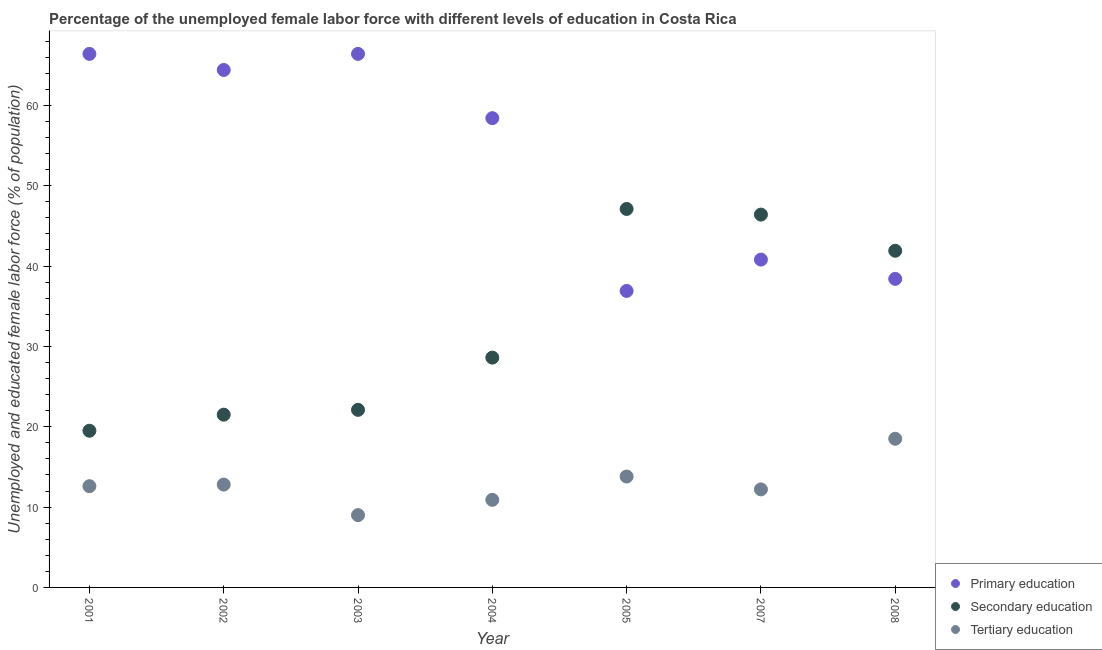What is the percentage of female labor force who received secondary education in 2005?
Keep it short and to the point. 47.1. What is the total percentage of female labor force who received tertiary education in the graph?
Provide a succinct answer. 89.8. What is the difference between the percentage of female labor force who received secondary education in 2001 and that in 2004?
Ensure brevity in your answer.  -9.1. What is the difference between the percentage of female labor force who received secondary education in 2005 and the percentage of female labor force who received tertiary education in 2008?
Your answer should be very brief. 28.6. What is the average percentage of female labor force who received primary education per year?
Provide a succinct answer. 53.1. In the year 2004, what is the difference between the percentage of female labor force who received tertiary education and percentage of female labor force who received secondary education?
Your answer should be very brief. -17.7. In how many years, is the percentage of female labor force who received primary education greater than 62 %?
Give a very brief answer. 3. What is the ratio of the percentage of female labor force who received primary education in 2001 to that in 2005?
Give a very brief answer. 1.8. Is the percentage of female labor force who received primary education in 2004 less than that in 2005?
Your answer should be very brief. No. What is the difference between the highest and the second highest percentage of female labor force who received secondary education?
Ensure brevity in your answer.  0.7. What is the difference between the highest and the lowest percentage of female labor force who received secondary education?
Your answer should be very brief. 27.6. In how many years, is the percentage of female labor force who received primary education greater than the average percentage of female labor force who received primary education taken over all years?
Make the answer very short. 4. Is the sum of the percentage of female labor force who received primary education in 2001 and 2008 greater than the maximum percentage of female labor force who received secondary education across all years?
Provide a short and direct response. Yes. Is the percentage of female labor force who received primary education strictly greater than the percentage of female labor force who received tertiary education over the years?
Your answer should be compact. Yes. Are the values on the major ticks of Y-axis written in scientific E-notation?
Give a very brief answer. No. Does the graph contain grids?
Offer a very short reply. No. Where does the legend appear in the graph?
Provide a succinct answer. Bottom right. How are the legend labels stacked?
Your response must be concise. Vertical. What is the title of the graph?
Provide a succinct answer. Percentage of the unemployed female labor force with different levels of education in Costa Rica. Does "Poland" appear as one of the legend labels in the graph?
Keep it short and to the point. No. What is the label or title of the X-axis?
Make the answer very short. Year. What is the label or title of the Y-axis?
Make the answer very short. Unemployed and educated female labor force (% of population). What is the Unemployed and educated female labor force (% of population) of Primary education in 2001?
Make the answer very short. 66.4. What is the Unemployed and educated female labor force (% of population) in Tertiary education in 2001?
Offer a very short reply. 12.6. What is the Unemployed and educated female labor force (% of population) of Primary education in 2002?
Your answer should be very brief. 64.4. What is the Unemployed and educated female labor force (% of population) of Tertiary education in 2002?
Provide a short and direct response. 12.8. What is the Unemployed and educated female labor force (% of population) of Primary education in 2003?
Make the answer very short. 66.4. What is the Unemployed and educated female labor force (% of population) in Secondary education in 2003?
Ensure brevity in your answer.  22.1. What is the Unemployed and educated female labor force (% of population) in Primary education in 2004?
Make the answer very short. 58.4. What is the Unemployed and educated female labor force (% of population) in Secondary education in 2004?
Ensure brevity in your answer.  28.6. What is the Unemployed and educated female labor force (% of population) in Tertiary education in 2004?
Give a very brief answer. 10.9. What is the Unemployed and educated female labor force (% of population) in Primary education in 2005?
Offer a terse response. 36.9. What is the Unemployed and educated female labor force (% of population) of Secondary education in 2005?
Your answer should be very brief. 47.1. What is the Unemployed and educated female labor force (% of population) of Tertiary education in 2005?
Provide a succinct answer. 13.8. What is the Unemployed and educated female labor force (% of population) of Primary education in 2007?
Provide a short and direct response. 40.8. What is the Unemployed and educated female labor force (% of population) in Secondary education in 2007?
Make the answer very short. 46.4. What is the Unemployed and educated female labor force (% of population) of Tertiary education in 2007?
Provide a short and direct response. 12.2. What is the Unemployed and educated female labor force (% of population) in Primary education in 2008?
Offer a very short reply. 38.4. What is the Unemployed and educated female labor force (% of population) in Secondary education in 2008?
Offer a terse response. 41.9. Across all years, what is the maximum Unemployed and educated female labor force (% of population) in Primary education?
Keep it short and to the point. 66.4. Across all years, what is the maximum Unemployed and educated female labor force (% of population) of Secondary education?
Your answer should be very brief. 47.1. Across all years, what is the maximum Unemployed and educated female labor force (% of population) of Tertiary education?
Your answer should be very brief. 18.5. Across all years, what is the minimum Unemployed and educated female labor force (% of population) in Primary education?
Make the answer very short. 36.9. Across all years, what is the minimum Unemployed and educated female labor force (% of population) of Secondary education?
Provide a succinct answer. 19.5. Across all years, what is the minimum Unemployed and educated female labor force (% of population) in Tertiary education?
Provide a succinct answer. 9. What is the total Unemployed and educated female labor force (% of population) in Primary education in the graph?
Give a very brief answer. 371.7. What is the total Unemployed and educated female labor force (% of population) in Secondary education in the graph?
Your response must be concise. 227.1. What is the total Unemployed and educated female labor force (% of population) in Tertiary education in the graph?
Keep it short and to the point. 89.8. What is the difference between the Unemployed and educated female labor force (% of population) of Primary education in 2001 and that in 2002?
Make the answer very short. 2. What is the difference between the Unemployed and educated female labor force (% of population) in Secondary education in 2001 and that in 2002?
Your answer should be very brief. -2. What is the difference between the Unemployed and educated female labor force (% of population) of Primary education in 2001 and that in 2003?
Keep it short and to the point. 0. What is the difference between the Unemployed and educated female labor force (% of population) of Primary education in 2001 and that in 2005?
Your response must be concise. 29.5. What is the difference between the Unemployed and educated female labor force (% of population) in Secondary education in 2001 and that in 2005?
Make the answer very short. -27.6. What is the difference between the Unemployed and educated female labor force (% of population) in Primary education in 2001 and that in 2007?
Ensure brevity in your answer.  25.6. What is the difference between the Unemployed and educated female labor force (% of population) of Secondary education in 2001 and that in 2007?
Your answer should be very brief. -26.9. What is the difference between the Unemployed and educated female labor force (% of population) in Secondary education in 2001 and that in 2008?
Give a very brief answer. -22.4. What is the difference between the Unemployed and educated female labor force (% of population) of Primary education in 2002 and that in 2003?
Your answer should be compact. -2. What is the difference between the Unemployed and educated female labor force (% of population) of Secondary education in 2002 and that in 2003?
Your answer should be very brief. -0.6. What is the difference between the Unemployed and educated female labor force (% of population) in Tertiary education in 2002 and that in 2003?
Your answer should be very brief. 3.8. What is the difference between the Unemployed and educated female labor force (% of population) in Secondary education in 2002 and that in 2004?
Your response must be concise. -7.1. What is the difference between the Unemployed and educated female labor force (% of population) of Tertiary education in 2002 and that in 2004?
Your response must be concise. 1.9. What is the difference between the Unemployed and educated female labor force (% of population) in Secondary education in 2002 and that in 2005?
Keep it short and to the point. -25.6. What is the difference between the Unemployed and educated female labor force (% of population) of Primary education in 2002 and that in 2007?
Your answer should be very brief. 23.6. What is the difference between the Unemployed and educated female labor force (% of population) in Secondary education in 2002 and that in 2007?
Offer a very short reply. -24.9. What is the difference between the Unemployed and educated female labor force (% of population) in Tertiary education in 2002 and that in 2007?
Ensure brevity in your answer.  0.6. What is the difference between the Unemployed and educated female labor force (% of population) of Primary education in 2002 and that in 2008?
Your response must be concise. 26. What is the difference between the Unemployed and educated female labor force (% of population) of Secondary education in 2002 and that in 2008?
Keep it short and to the point. -20.4. What is the difference between the Unemployed and educated female labor force (% of population) of Tertiary education in 2002 and that in 2008?
Your answer should be compact. -5.7. What is the difference between the Unemployed and educated female labor force (% of population) of Primary education in 2003 and that in 2004?
Provide a short and direct response. 8. What is the difference between the Unemployed and educated female labor force (% of population) of Tertiary education in 2003 and that in 2004?
Your response must be concise. -1.9. What is the difference between the Unemployed and educated female labor force (% of population) of Primary education in 2003 and that in 2005?
Provide a short and direct response. 29.5. What is the difference between the Unemployed and educated female labor force (% of population) in Primary education in 2003 and that in 2007?
Make the answer very short. 25.6. What is the difference between the Unemployed and educated female labor force (% of population) of Secondary education in 2003 and that in 2007?
Make the answer very short. -24.3. What is the difference between the Unemployed and educated female labor force (% of population) in Tertiary education in 2003 and that in 2007?
Offer a very short reply. -3.2. What is the difference between the Unemployed and educated female labor force (% of population) of Secondary education in 2003 and that in 2008?
Your response must be concise. -19.8. What is the difference between the Unemployed and educated female labor force (% of population) of Secondary education in 2004 and that in 2005?
Provide a succinct answer. -18.5. What is the difference between the Unemployed and educated female labor force (% of population) of Tertiary education in 2004 and that in 2005?
Your answer should be very brief. -2.9. What is the difference between the Unemployed and educated female labor force (% of population) of Secondary education in 2004 and that in 2007?
Give a very brief answer. -17.8. What is the difference between the Unemployed and educated female labor force (% of population) of Tertiary education in 2004 and that in 2007?
Give a very brief answer. -1.3. What is the difference between the Unemployed and educated female labor force (% of population) in Primary education in 2004 and that in 2008?
Offer a very short reply. 20. What is the difference between the Unemployed and educated female labor force (% of population) in Tertiary education in 2004 and that in 2008?
Provide a short and direct response. -7.6. What is the difference between the Unemployed and educated female labor force (% of population) of Primary education in 2005 and that in 2007?
Offer a terse response. -3.9. What is the difference between the Unemployed and educated female labor force (% of population) of Tertiary education in 2005 and that in 2007?
Offer a terse response. 1.6. What is the difference between the Unemployed and educated female labor force (% of population) of Secondary education in 2005 and that in 2008?
Make the answer very short. 5.2. What is the difference between the Unemployed and educated female labor force (% of population) of Tertiary education in 2005 and that in 2008?
Offer a very short reply. -4.7. What is the difference between the Unemployed and educated female labor force (% of population) in Primary education in 2007 and that in 2008?
Ensure brevity in your answer.  2.4. What is the difference between the Unemployed and educated female labor force (% of population) of Secondary education in 2007 and that in 2008?
Give a very brief answer. 4.5. What is the difference between the Unemployed and educated female labor force (% of population) of Primary education in 2001 and the Unemployed and educated female labor force (% of population) of Secondary education in 2002?
Ensure brevity in your answer.  44.9. What is the difference between the Unemployed and educated female labor force (% of population) of Primary education in 2001 and the Unemployed and educated female labor force (% of population) of Tertiary education in 2002?
Ensure brevity in your answer.  53.6. What is the difference between the Unemployed and educated female labor force (% of population) in Secondary education in 2001 and the Unemployed and educated female labor force (% of population) in Tertiary education in 2002?
Your answer should be compact. 6.7. What is the difference between the Unemployed and educated female labor force (% of population) of Primary education in 2001 and the Unemployed and educated female labor force (% of population) of Secondary education in 2003?
Ensure brevity in your answer.  44.3. What is the difference between the Unemployed and educated female labor force (% of population) of Primary education in 2001 and the Unemployed and educated female labor force (% of population) of Tertiary education in 2003?
Provide a succinct answer. 57.4. What is the difference between the Unemployed and educated female labor force (% of population) of Primary education in 2001 and the Unemployed and educated female labor force (% of population) of Secondary education in 2004?
Make the answer very short. 37.8. What is the difference between the Unemployed and educated female labor force (% of population) in Primary education in 2001 and the Unemployed and educated female labor force (% of population) in Tertiary education in 2004?
Make the answer very short. 55.5. What is the difference between the Unemployed and educated female labor force (% of population) of Primary education in 2001 and the Unemployed and educated female labor force (% of population) of Secondary education in 2005?
Give a very brief answer. 19.3. What is the difference between the Unemployed and educated female labor force (% of population) in Primary education in 2001 and the Unemployed and educated female labor force (% of population) in Tertiary education in 2005?
Provide a short and direct response. 52.6. What is the difference between the Unemployed and educated female labor force (% of population) of Secondary education in 2001 and the Unemployed and educated female labor force (% of population) of Tertiary education in 2005?
Ensure brevity in your answer.  5.7. What is the difference between the Unemployed and educated female labor force (% of population) of Primary education in 2001 and the Unemployed and educated female labor force (% of population) of Tertiary education in 2007?
Provide a succinct answer. 54.2. What is the difference between the Unemployed and educated female labor force (% of population) in Primary education in 2001 and the Unemployed and educated female labor force (% of population) in Secondary education in 2008?
Your response must be concise. 24.5. What is the difference between the Unemployed and educated female labor force (% of population) in Primary education in 2001 and the Unemployed and educated female labor force (% of population) in Tertiary education in 2008?
Provide a short and direct response. 47.9. What is the difference between the Unemployed and educated female labor force (% of population) in Primary education in 2002 and the Unemployed and educated female labor force (% of population) in Secondary education in 2003?
Keep it short and to the point. 42.3. What is the difference between the Unemployed and educated female labor force (% of population) of Primary education in 2002 and the Unemployed and educated female labor force (% of population) of Tertiary education in 2003?
Your answer should be compact. 55.4. What is the difference between the Unemployed and educated female labor force (% of population) in Primary education in 2002 and the Unemployed and educated female labor force (% of population) in Secondary education in 2004?
Offer a terse response. 35.8. What is the difference between the Unemployed and educated female labor force (% of population) of Primary education in 2002 and the Unemployed and educated female labor force (% of population) of Tertiary education in 2004?
Your response must be concise. 53.5. What is the difference between the Unemployed and educated female labor force (% of population) in Secondary education in 2002 and the Unemployed and educated female labor force (% of population) in Tertiary education in 2004?
Offer a terse response. 10.6. What is the difference between the Unemployed and educated female labor force (% of population) of Primary education in 2002 and the Unemployed and educated female labor force (% of population) of Secondary education in 2005?
Keep it short and to the point. 17.3. What is the difference between the Unemployed and educated female labor force (% of population) in Primary education in 2002 and the Unemployed and educated female labor force (% of population) in Tertiary education in 2005?
Offer a terse response. 50.6. What is the difference between the Unemployed and educated female labor force (% of population) in Primary education in 2002 and the Unemployed and educated female labor force (% of population) in Secondary education in 2007?
Your response must be concise. 18. What is the difference between the Unemployed and educated female labor force (% of population) in Primary education in 2002 and the Unemployed and educated female labor force (% of population) in Tertiary education in 2007?
Provide a short and direct response. 52.2. What is the difference between the Unemployed and educated female labor force (% of population) in Primary education in 2002 and the Unemployed and educated female labor force (% of population) in Secondary education in 2008?
Ensure brevity in your answer.  22.5. What is the difference between the Unemployed and educated female labor force (% of population) in Primary education in 2002 and the Unemployed and educated female labor force (% of population) in Tertiary education in 2008?
Offer a terse response. 45.9. What is the difference between the Unemployed and educated female labor force (% of population) in Secondary education in 2002 and the Unemployed and educated female labor force (% of population) in Tertiary education in 2008?
Ensure brevity in your answer.  3. What is the difference between the Unemployed and educated female labor force (% of population) in Primary education in 2003 and the Unemployed and educated female labor force (% of population) in Secondary education in 2004?
Provide a short and direct response. 37.8. What is the difference between the Unemployed and educated female labor force (% of population) of Primary education in 2003 and the Unemployed and educated female labor force (% of population) of Tertiary education in 2004?
Give a very brief answer. 55.5. What is the difference between the Unemployed and educated female labor force (% of population) of Secondary education in 2003 and the Unemployed and educated female labor force (% of population) of Tertiary education in 2004?
Your answer should be compact. 11.2. What is the difference between the Unemployed and educated female labor force (% of population) of Primary education in 2003 and the Unemployed and educated female labor force (% of population) of Secondary education in 2005?
Your answer should be compact. 19.3. What is the difference between the Unemployed and educated female labor force (% of population) of Primary education in 2003 and the Unemployed and educated female labor force (% of population) of Tertiary education in 2005?
Your answer should be compact. 52.6. What is the difference between the Unemployed and educated female labor force (% of population) of Primary education in 2003 and the Unemployed and educated female labor force (% of population) of Tertiary education in 2007?
Make the answer very short. 54.2. What is the difference between the Unemployed and educated female labor force (% of population) of Secondary education in 2003 and the Unemployed and educated female labor force (% of population) of Tertiary education in 2007?
Offer a very short reply. 9.9. What is the difference between the Unemployed and educated female labor force (% of population) of Primary education in 2003 and the Unemployed and educated female labor force (% of population) of Tertiary education in 2008?
Your answer should be very brief. 47.9. What is the difference between the Unemployed and educated female labor force (% of population) in Secondary education in 2003 and the Unemployed and educated female labor force (% of population) in Tertiary education in 2008?
Ensure brevity in your answer.  3.6. What is the difference between the Unemployed and educated female labor force (% of population) in Primary education in 2004 and the Unemployed and educated female labor force (% of population) in Secondary education in 2005?
Offer a very short reply. 11.3. What is the difference between the Unemployed and educated female labor force (% of population) of Primary education in 2004 and the Unemployed and educated female labor force (% of population) of Tertiary education in 2005?
Your answer should be very brief. 44.6. What is the difference between the Unemployed and educated female labor force (% of population) in Secondary education in 2004 and the Unemployed and educated female labor force (% of population) in Tertiary education in 2005?
Your answer should be very brief. 14.8. What is the difference between the Unemployed and educated female labor force (% of population) in Primary education in 2004 and the Unemployed and educated female labor force (% of population) in Tertiary education in 2007?
Offer a very short reply. 46.2. What is the difference between the Unemployed and educated female labor force (% of population) of Secondary education in 2004 and the Unemployed and educated female labor force (% of population) of Tertiary education in 2007?
Offer a very short reply. 16.4. What is the difference between the Unemployed and educated female labor force (% of population) of Primary education in 2004 and the Unemployed and educated female labor force (% of population) of Secondary education in 2008?
Your answer should be very brief. 16.5. What is the difference between the Unemployed and educated female labor force (% of population) of Primary education in 2004 and the Unemployed and educated female labor force (% of population) of Tertiary education in 2008?
Your answer should be compact. 39.9. What is the difference between the Unemployed and educated female labor force (% of population) in Primary education in 2005 and the Unemployed and educated female labor force (% of population) in Secondary education in 2007?
Ensure brevity in your answer.  -9.5. What is the difference between the Unemployed and educated female labor force (% of population) in Primary education in 2005 and the Unemployed and educated female labor force (% of population) in Tertiary education in 2007?
Provide a short and direct response. 24.7. What is the difference between the Unemployed and educated female labor force (% of population) in Secondary education in 2005 and the Unemployed and educated female labor force (% of population) in Tertiary education in 2007?
Offer a very short reply. 34.9. What is the difference between the Unemployed and educated female labor force (% of population) in Secondary education in 2005 and the Unemployed and educated female labor force (% of population) in Tertiary education in 2008?
Provide a succinct answer. 28.6. What is the difference between the Unemployed and educated female labor force (% of population) in Primary education in 2007 and the Unemployed and educated female labor force (% of population) in Tertiary education in 2008?
Make the answer very short. 22.3. What is the difference between the Unemployed and educated female labor force (% of population) of Secondary education in 2007 and the Unemployed and educated female labor force (% of population) of Tertiary education in 2008?
Your response must be concise. 27.9. What is the average Unemployed and educated female labor force (% of population) of Primary education per year?
Your response must be concise. 53.1. What is the average Unemployed and educated female labor force (% of population) in Secondary education per year?
Give a very brief answer. 32.44. What is the average Unemployed and educated female labor force (% of population) in Tertiary education per year?
Give a very brief answer. 12.83. In the year 2001, what is the difference between the Unemployed and educated female labor force (% of population) in Primary education and Unemployed and educated female labor force (% of population) in Secondary education?
Your answer should be very brief. 46.9. In the year 2001, what is the difference between the Unemployed and educated female labor force (% of population) in Primary education and Unemployed and educated female labor force (% of population) in Tertiary education?
Offer a terse response. 53.8. In the year 2002, what is the difference between the Unemployed and educated female labor force (% of population) in Primary education and Unemployed and educated female labor force (% of population) in Secondary education?
Offer a very short reply. 42.9. In the year 2002, what is the difference between the Unemployed and educated female labor force (% of population) of Primary education and Unemployed and educated female labor force (% of population) of Tertiary education?
Provide a succinct answer. 51.6. In the year 2002, what is the difference between the Unemployed and educated female labor force (% of population) in Secondary education and Unemployed and educated female labor force (% of population) in Tertiary education?
Offer a terse response. 8.7. In the year 2003, what is the difference between the Unemployed and educated female labor force (% of population) in Primary education and Unemployed and educated female labor force (% of population) in Secondary education?
Offer a terse response. 44.3. In the year 2003, what is the difference between the Unemployed and educated female labor force (% of population) in Primary education and Unemployed and educated female labor force (% of population) in Tertiary education?
Offer a very short reply. 57.4. In the year 2003, what is the difference between the Unemployed and educated female labor force (% of population) of Secondary education and Unemployed and educated female labor force (% of population) of Tertiary education?
Your response must be concise. 13.1. In the year 2004, what is the difference between the Unemployed and educated female labor force (% of population) in Primary education and Unemployed and educated female labor force (% of population) in Secondary education?
Your response must be concise. 29.8. In the year 2004, what is the difference between the Unemployed and educated female labor force (% of population) in Primary education and Unemployed and educated female labor force (% of population) in Tertiary education?
Make the answer very short. 47.5. In the year 2005, what is the difference between the Unemployed and educated female labor force (% of population) of Primary education and Unemployed and educated female labor force (% of population) of Secondary education?
Your response must be concise. -10.2. In the year 2005, what is the difference between the Unemployed and educated female labor force (% of population) of Primary education and Unemployed and educated female labor force (% of population) of Tertiary education?
Provide a succinct answer. 23.1. In the year 2005, what is the difference between the Unemployed and educated female labor force (% of population) of Secondary education and Unemployed and educated female labor force (% of population) of Tertiary education?
Your answer should be compact. 33.3. In the year 2007, what is the difference between the Unemployed and educated female labor force (% of population) of Primary education and Unemployed and educated female labor force (% of population) of Tertiary education?
Your response must be concise. 28.6. In the year 2007, what is the difference between the Unemployed and educated female labor force (% of population) of Secondary education and Unemployed and educated female labor force (% of population) of Tertiary education?
Give a very brief answer. 34.2. In the year 2008, what is the difference between the Unemployed and educated female labor force (% of population) of Secondary education and Unemployed and educated female labor force (% of population) of Tertiary education?
Your answer should be very brief. 23.4. What is the ratio of the Unemployed and educated female labor force (% of population) of Primary education in 2001 to that in 2002?
Provide a succinct answer. 1.03. What is the ratio of the Unemployed and educated female labor force (% of population) of Secondary education in 2001 to that in 2002?
Provide a succinct answer. 0.91. What is the ratio of the Unemployed and educated female labor force (% of population) of Tertiary education in 2001 to that in 2002?
Give a very brief answer. 0.98. What is the ratio of the Unemployed and educated female labor force (% of population) of Primary education in 2001 to that in 2003?
Your answer should be very brief. 1. What is the ratio of the Unemployed and educated female labor force (% of population) of Secondary education in 2001 to that in 2003?
Your answer should be compact. 0.88. What is the ratio of the Unemployed and educated female labor force (% of population) of Tertiary education in 2001 to that in 2003?
Offer a terse response. 1.4. What is the ratio of the Unemployed and educated female labor force (% of population) in Primary education in 2001 to that in 2004?
Your answer should be very brief. 1.14. What is the ratio of the Unemployed and educated female labor force (% of population) in Secondary education in 2001 to that in 2004?
Offer a very short reply. 0.68. What is the ratio of the Unemployed and educated female labor force (% of population) of Tertiary education in 2001 to that in 2004?
Make the answer very short. 1.16. What is the ratio of the Unemployed and educated female labor force (% of population) in Primary education in 2001 to that in 2005?
Offer a very short reply. 1.8. What is the ratio of the Unemployed and educated female labor force (% of population) of Secondary education in 2001 to that in 2005?
Your answer should be compact. 0.41. What is the ratio of the Unemployed and educated female labor force (% of population) in Primary education in 2001 to that in 2007?
Provide a succinct answer. 1.63. What is the ratio of the Unemployed and educated female labor force (% of population) in Secondary education in 2001 to that in 2007?
Provide a succinct answer. 0.42. What is the ratio of the Unemployed and educated female labor force (% of population) of Tertiary education in 2001 to that in 2007?
Your answer should be compact. 1.03. What is the ratio of the Unemployed and educated female labor force (% of population) in Primary education in 2001 to that in 2008?
Give a very brief answer. 1.73. What is the ratio of the Unemployed and educated female labor force (% of population) of Secondary education in 2001 to that in 2008?
Ensure brevity in your answer.  0.47. What is the ratio of the Unemployed and educated female labor force (% of population) in Tertiary education in 2001 to that in 2008?
Provide a succinct answer. 0.68. What is the ratio of the Unemployed and educated female labor force (% of population) of Primary education in 2002 to that in 2003?
Your response must be concise. 0.97. What is the ratio of the Unemployed and educated female labor force (% of population) of Secondary education in 2002 to that in 2003?
Give a very brief answer. 0.97. What is the ratio of the Unemployed and educated female labor force (% of population) of Tertiary education in 2002 to that in 2003?
Your response must be concise. 1.42. What is the ratio of the Unemployed and educated female labor force (% of population) of Primary education in 2002 to that in 2004?
Your response must be concise. 1.1. What is the ratio of the Unemployed and educated female labor force (% of population) in Secondary education in 2002 to that in 2004?
Keep it short and to the point. 0.75. What is the ratio of the Unemployed and educated female labor force (% of population) in Tertiary education in 2002 to that in 2004?
Offer a terse response. 1.17. What is the ratio of the Unemployed and educated female labor force (% of population) of Primary education in 2002 to that in 2005?
Offer a very short reply. 1.75. What is the ratio of the Unemployed and educated female labor force (% of population) in Secondary education in 2002 to that in 2005?
Make the answer very short. 0.46. What is the ratio of the Unemployed and educated female labor force (% of population) of Tertiary education in 2002 to that in 2005?
Your answer should be compact. 0.93. What is the ratio of the Unemployed and educated female labor force (% of population) in Primary education in 2002 to that in 2007?
Ensure brevity in your answer.  1.58. What is the ratio of the Unemployed and educated female labor force (% of population) of Secondary education in 2002 to that in 2007?
Your answer should be very brief. 0.46. What is the ratio of the Unemployed and educated female labor force (% of population) in Tertiary education in 2002 to that in 2007?
Give a very brief answer. 1.05. What is the ratio of the Unemployed and educated female labor force (% of population) of Primary education in 2002 to that in 2008?
Your response must be concise. 1.68. What is the ratio of the Unemployed and educated female labor force (% of population) of Secondary education in 2002 to that in 2008?
Your answer should be very brief. 0.51. What is the ratio of the Unemployed and educated female labor force (% of population) of Tertiary education in 2002 to that in 2008?
Your answer should be compact. 0.69. What is the ratio of the Unemployed and educated female labor force (% of population) of Primary education in 2003 to that in 2004?
Your answer should be very brief. 1.14. What is the ratio of the Unemployed and educated female labor force (% of population) of Secondary education in 2003 to that in 2004?
Your answer should be compact. 0.77. What is the ratio of the Unemployed and educated female labor force (% of population) of Tertiary education in 2003 to that in 2004?
Keep it short and to the point. 0.83. What is the ratio of the Unemployed and educated female labor force (% of population) of Primary education in 2003 to that in 2005?
Your answer should be very brief. 1.8. What is the ratio of the Unemployed and educated female labor force (% of population) of Secondary education in 2003 to that in 2005?
Your answer should be very brief. 0.47. What is the ratio of the Unemployed and educated female labor force (% of population) in Tertiary education in 2003 to that in 2005?
Offer a terse response. 0.65. What is the ratio of the Unemployed and educated female labor force (% of population) of Primary education in 2003 to that in 2007?
Your answer should be very brief. 1.63. What is the ratio of the Unemployed and educated female labor force (% of population) of Secondary education in 2003 to that in 2007?
Provide a succinct answer. 0.48. What is the ratio of the Unemployed and educated female labor force (% of population) of Tertiary education in 2003 to that in 2007?
Your answer should be compact. 0.74. What is the ratio of the Unemployed and educated female labor force (% of population) in Primary education in 2003 to that in 2008?
Provide a short and direct response. 1.73. What is the ratio of the Unemployed and educated female labor force (% of population) of Secondary education in 2003 to that in 2008?
Offer a terse response. 0.53. What is the ratio of the Unemployed and educated female labor force (% of population) of Tertiary education in 2003 to that in 2008?
Your answer should be very brief. 0.49. What is the ratio of the Unemployed and educated female labor force (% of population) in Primary education in 2004 to that in 2005?
Keep it short and to the point. 1.58. What is the ratio of the Unemployed and educated female labor force (% of population) of Secondary education in 2004 to that in 2005?
Your response must be concise. 0.61. What is the ratio of the Unemployed and educated female labor force (% of population) of Tertiary education in 2004 to that in 2005?
Offer a terse response. 0.79. What is the ratio of the Unemployed and educated female labor force (% of population) in Primary education in 2004 to that in 2007?
Your answer should be very brief. 1.43. What is the ratio of the Unemployed and educated female labor force (% of population) of Secondary education in 2004 to that in 2007?
Keep it short and to the point. 0.62. What is the ratio of the Unemployed and educated female labor force (% of population) of Tertiary education in 2004 to that in 2007?
Keep it short and to the point. 0.89. What is the ratio of the Unemployed and educated female labor force (% of population) in Primary education in 2004 to that in 2008?
Your answer should be compact. 1.52. What is the ratio of the Unemployed and educated female labor force (% of population) in Secondary education in 2004 to that in 2008?
Your response must be concise. 0.68. What is the ratio of the Unemployed and educated female labor force (% of population) in Tertiary education in 2004 to that in 2008?
Keep it short and to the point. 0.59. What is the ratio of the Unemployed and educated female labor force (% of population) in Primary education in 2005 to that in 2007?
Keep it short and to the point. 0.9. What is the ratio of the Unemployed and educated female labor force (% of population) in Secondary education in 2005 to that in 2007?
Provide a succinct answer. 1.02. What is the ratio of the Unemployed and educated female labor force (% of population) of Tertiary education in 2005 to that in 2007?
Your answer should be compact. 1.13. What is the ratio of the Unemployed and educated female labor force (% of population) in Primary education in 2005 to that in 2008?
Your response must be concise. 0.96. What is the ratio of the Unemployed and educated female labor force (% of population) of Secondary education in 2005 to that in 2008?
Offer a very short reply. 1.12. What is the ratio of the Unemployed and educated female labor force (% of population) in Tertiary education in 2005 to that in 2008?
Your answer should be very brief. 0.75. What is the ratio of the Unemployed and educated female labor force (% of population) in Primary education in 2007 to that in 2008?
Make the answer very short. 1.06. What is the ratio of the Unemployed and educated female labor force (% of population) of Secondary education in 2007 to that in 2008?
Your response must be concise. 1.11. What is the ratio of the Unemployed and educated female labor force (% of population) of Tertiary education in 2007 to that in 2008?
Make the answer very short. 0.66. What is the difference between the highest and the second highest Unemployed and educated female labor force (% of population) in Primary education?
Ensure brevity in your answer.  0. What is the difference between the highest and the second highest Unemployed and educated female labor force (% of population) in Secondary education?
Your answer should be very brief. 0.7. What is the difference between the highest and the second highest Unemployed and educated female labor force (% of population) of Tertiary education?
Ensure brevity in your answer.  4.7. What is the difference between the highest and the lowest Unemployed and educated female labor force (% of population) in Primary education?
Offer a very short reply. 29.5. What is the difference between the highest and the lowest Unemployed and educated female labor force (% of population) in Secondary education?
Keep it short and to the point. 27.6. 